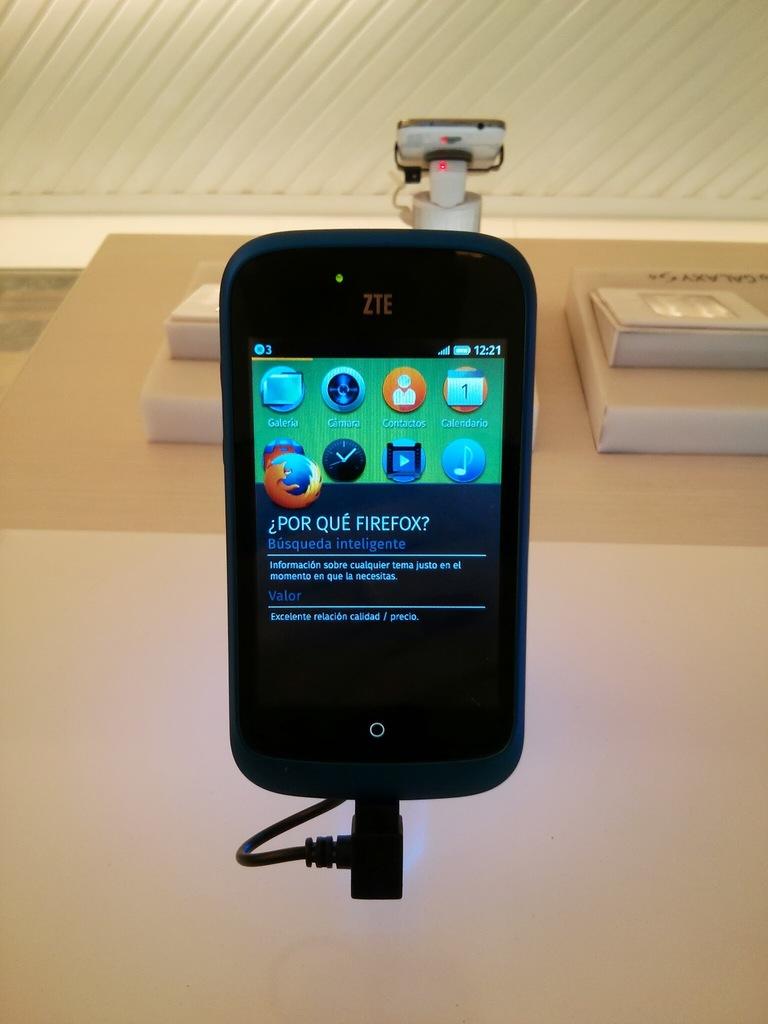What time is displayed?
Your answer should be very brief. 12:21. 